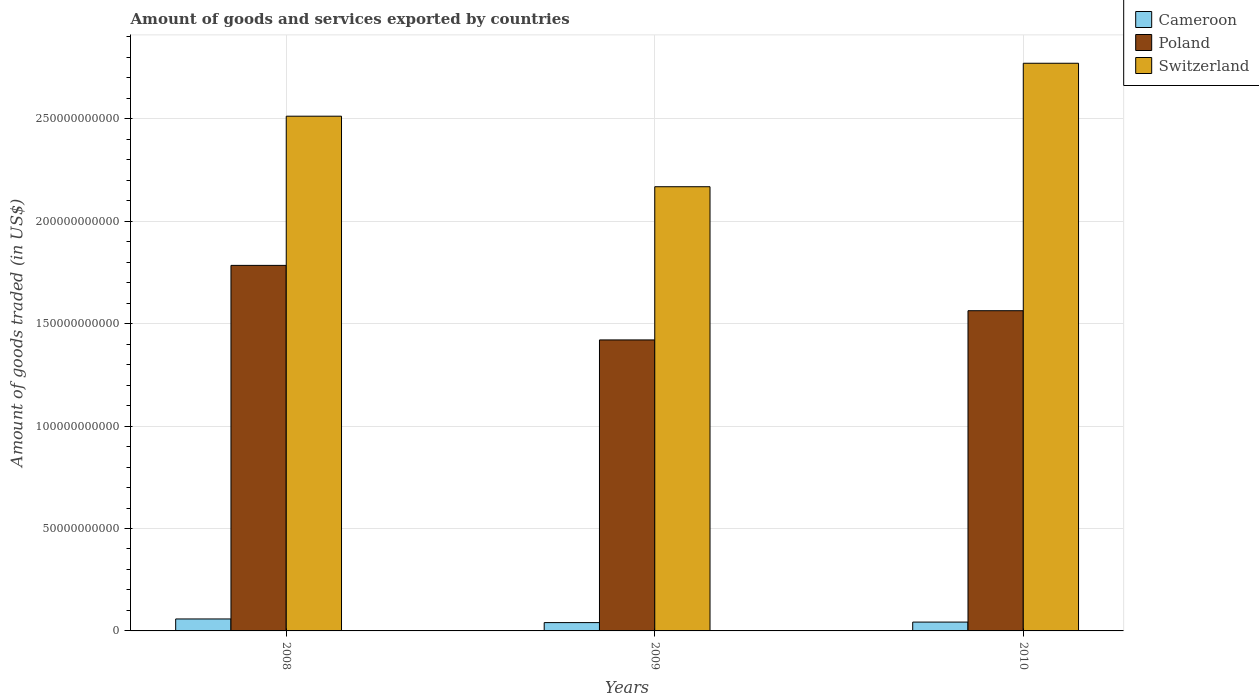How many different coloured bars are there?
Make the answer very short. 3. Are the number of bars on each tick of the X-axis equal?
Ensure brevity in your answer.  Yes. How many bars are there on the 3rd tick from the left?
Give a very brief answer. 3. How many bars are there on the 1st tick from the right?
Provide a short and direct response. 3. What is the total amount of goods and services exported in Cameroon in 2009?
Provide a succinct answer. 4.06e+09. Across all years, what is the maximum total amount of goods and services exported in Switzerland?
Provide a short and direct response. 2.77e+11. Across all years, what is the minimum total amount of goods and services exported in Switzerland?
Your response must be concise. 2.17e+11. What is the total total amount of goods and services exported in Poland in the graph?
Provide a succinct answer. 4.77e+11. What is the difference between the total amount of goods and services exported in Switzerland in 2008 and that in 2010?
Make the answer very short. -2.58e+1. What is the difference between the total amount of goods and services exported in Cameroon in 2010 and the total amount of goods and services exported in Switzerland in 2009?
Provide a short and direct response. -2.13e+11. What is the average total amount of goods and services exported in Switzerland per year?
Your answer should be very brief. 2.48e+11. In the year 2009, what is the difference between the total amount of goods and services exported in Cameroon and total amount of goods and services exported in Switzerland?
Your response must be concise. -2.13e+11. What is the ratio of the total amount of goods and services exported in Switzerland in 2008 to that in 2009?
Offer a very short reply. 1.16. Is the difference between the total amount of goods and services exported in Cameroon in 2008 and 2010 greater than the difference between the total amount of goods and services exported in Switzerland in 2008 and 2010?
Provide a succinct answer. Yes. What is the difference between the highest and the second highest total amount of goods and services exported in Switzerland?
Provide a succinct answer. 2.58e+1. What is the difference between the highest and the lowest total amount of goods and services exported in Switzerland?
Offer a terse response. 6.03e+1. In how many years, is the total amount of goods and services exported in Poland greater than the average total amount of goods and services exported in Poland taken over all years?
Your answer should be very brief. 1. What does the 2nd bar from the left in 2010 represents?
Your answer should be very brief. Poland. What does the 1st bar from the right in 2010 represents?
Provide a succinct answer. Switzerland. Is it the case that in every year, the sum of the total amount of goods and services exported in Switzerland and total amount of goods and services exported in Cameroon is greater than the total amount of goods and services exported in Poland?
Offer a terse response. Yes. Are all the bars in the graph horizontal?
Provide a succinct answer. No. How many years are there in the graph?
Provide a succinct answer. 3. Are the values on the major ticks of Y-axis written in scientific E-notation?
Ensure brevity in your answer.  No. Does the graph contain any zero values?
Make the answer very short. No. What is the title of the graph?
Your answer should be compact. Amount of goods and services exported by countries. Does "Turkmenistan" appear as one of the legend labels in the graph?
Offer a terse response. No. What is the label or title of the Y-axis?
Give a very brief answer. Amount of goods traded (in US$). What is the Amount of goods traded (in US$) in Cameroon in 2008?
Your answer should be compact. 5.84e+09. What is the Amount of goods traded (in US$) in Poland in 2008?
Ensure brevity in your answer.  1.78e+11. What is the Amount of goods traded (in US$) in Switzerland in 2008?
Make the answer very short. 2.51e+11. What is the Amount of goods traded (in US$) in Cameroon in 2009?
Make the answer very short. 4.06e+09. What is the Amount of goods traded (in US$) in Poland in 2009?
Offer a terse response. 1.42e+11. What is the Amount of goods traded (in US$) of Switzerland in 2009?
Provide a short and direct response. 2.17e+11. What is the Amount of goods traded (in US$) in Cameroon in 2010?
Keep it short and to the point. 4.31e+09. What is the Amount of goods traded (in US$) in Poland in 2010?
Offer a terse response. 1.56e+11. What is the Amount of goods traded (in US$) in Switzerland in 2010?
Offer a terse response. 2.77e+11. Across all years, what is the maximum Amount of goods traded (in US$) in Cameroon?
Give a very brief answer. 5.84e+09. Across all years, what is the maximum Amount of goods traded (in US$) of Poland?
Offer a very short reply. 1.78e+11. Across all years, what is the maximum Amount of goods traded (in US$) in Switzerland?
Make the answer very short. 2.77e+11. Across all years, what is the minimum Amount of goods traded (in US$) of Cameroon?
Make the answer very short. 4.06e+09. Across all years, what is the minimum Amount of goods traded (in US$) of Poland?
Your response must be concise. 1.42e+11. Across all years, what is the minimum Amount of goods traded (in US$) of Switzerland?
Your answer should be compact. 2.17e+11. What is the total Amount of goods traded (in US$) in Cameroon in the graph?
Offer a terse response. 1.42e+1. What is the total Amount of goods traded (in US$) in Poland in the graph?
Your answer should be compact. 4.77e+11. What is the total Amount of goods traded (in US$) of Switzerland in the graph?
Keep it short and to the point. 7.45e+11. What is the difference between the Amount of goods traded (in US$) in Cameroon in 2008 and that in 2009?
Your answer should be very brief. 1.78e+09. What is the difference between the Amount of goods traded (in US$) in Poland in 2008 and that in 2009?
Give a very brief answer. 3.64e+1. What is the difference between the Amount of goods traded (in US$) of Switzerland in 2008 and that in 2009?
Give a very brief answer. 3.44e+1. What is the difference between the Amount of goods traded (in US$) of Cameroon in 2008 and that in 2010?
Give a very brief answer. 1.53e+09. What is the difference between the Amount of goods traded (in US$) of Poland in 2008 and that in 2010?
Provide a short and direct response. 2.21e+1. What is the difference between the Amount of goods traded (in US$) of Switzerland in 2008 and that in 2010?
Your answer should be very brief. -2.58e+1. What is the difference between the Amount of goods traded (in US$) of Cameroon in 2009 and that in 2010?
Give a very brief answer. -2.49e+08. What is the difference between the Amount of goods traded (in US$) in Poland in 2009 and that in 2010?
Ensure brevity in your answer.  -1.43e+1. What is the difference between the Amount of goods traded (in US$) in Switzerland in 2009 and that in 2010?
Keep it short and to the point. -6.03e+1. What is the difference between the Amount of goods traded (in US$) of Cameroon in 2008 and the Amount of goods traded (in US$) of Poland in 2009?
Your answer should be very brief. -1.36e+11. What is the difference between the Amount of goods traded (in US$) of Cameroon in 2008 and the Amount of goods traded (in US$) of Switzerland in 2009?
Your answer should be very brief. -2.11e+11. What is the difference between the Amount of goods traded (in US$) in Poland in 2008 and the Amount of goods traded (in US$) in Switzerland in 2009?
Your answer should be compact. -3.84e+1. What is the difference between the Amount of goods traded (in US$) of Cameroon in 2008 and the Amount of goods traded (in US$) of Poland in 2010?
Make the answer very short. -1.51e+11. What is the difference between the Amount of goods traded (in US$) in Cameroon in 2008 and the Amount of goods traded (in US$) in Switzerland in 2010?
Make the answer very short. -2.71e+11. What is the difference between the Amount of goods traded (in US$) in Poland in 2008 and the Amount of goods traded (in US$) in Switzerland in 2010?
Provide a short and direct response. -9.87e+1. What is the difference between the Amount of goods traded (in US$) in Cameroon in 2009 and the Amount of goods traded (in US$) in Poland in 2010?
Your answer should be very brief. -1.52e+11. What is the difference between the Amount of goods traded (in US$) in Cameroon in 2009 and the Amount of goods traded (in US$) in Switzerland in 2010?
Ensure brevity in your answer.  -2.73e+11. What is the difference between the Amount of goods traded (in US$) of Poland in 2009 and the Amount of goods traded (in US$) of Switzerland in 2010?
Give a very brief answer. -1.35e+11. What is the average Amount of goods traded (in US$) of Cameroon per year?
Your answer should be compact. 4.74e+09. What is the average Amount of goods traded (in US$) of Poland per year?
Make the answer very short. 1.59e+11. What is the average Amount of goods traded (in US$) of Switzerland per year?
Provide a short and direct response. 2.48e+11. In the year 2008, what is the difference between the Amount of goods traded (in US$) of Cameroon and Amount of goods traded (in US$) of Poland?
Your answer should be compact. -1.73e+11. In the year 2008, what is the difference between the Amount of goods traded (in US$) in Cameroon and Amount of goods traded (in US$) in Switzerland?
Offer a terse response. -2.45e+11. In the year 2008, what is the difference between the Amount of goods traded (in US$) in Poland and Amount of goods traded (in US$) in Switzerland?
Offer a terse response. -7.28e+1. In the year 2009, what is the difference between the Amount of goods traded (in US$) of Cameroon and Amount of goods traded (in US$) of Poland?
Your answer should be very brief. -1.38e+11. In the year 2009, what is the difference between the Amount of goods traded (in US$) of Cameroon and Amount of goods traded (in US$) of Switzerland?
Provide a short and direct response. -2.13e+11. In the year 2009, what is the difference between the Amount of goods traded (in US$) of Poland and Amount of goods traded (in US$) of Switzerland?
Offer a terse response. -7.48e+1. In the year 2010, what is the difference between the Amount of goods traded (in US$) in Cameroon and Amount of goods traded (in US$) in Poland?
Ensure brevity in your answer.  -1.52e+11. In the year 2010, what is the difference between the Amount of goods traded (in US$) of Cameroon and Amount of goods traded (in US$) of Switzerland?
Make the answer very short. -2.73e+11. In the year 2010, what is the difference between the Amount of goods traded (in US$) of Poland and Amount of goods traded (in US$) of Switzerland?
Your answer should be very brief. -1.21e+11. What is the ratio of the Amount of goods traded (in US$) in Cameroon in 2008 to that in 2009?
Ensure brevity in your answer.  1.44. What is the ratio of the Amount of goods traded (in US$) of Poland in 2008 to that in 2009?
Your answer should be very brief. 1.26. What is the ratio of the Amount of goods traded (in US$) in Switzerland in 2008 to that in 2009?
Your answer should be very brief. 1.16. What is the ratio of the Amount of goods traded (in US$) in Cameroon in 2008 to that in 2010?
Ensure brevity in your answer.  1.35. What is the ratio of the Amount of goods traded (in US$) in Poland in 2008 to that in 2010?
Offer a very short reply. 1.14. What is the ratio of the Amount of goods traded (in US$) of Switzerland in 2008 to that in 2010?
Offer a terse response. 0.91. What is the ratio of the Amount of goods traded (in US$) in Cameroon in 2009 to that in 2010?
Keep it short and to the point. 0.94. What is the ratio of the Amount of goods traded (in US$) of Poland in 2009 to that in 2010?
Provide a succinct answer. 0.91. What is the ratio of the Amount of goods traded (in US$) in Switzerland in 2009 to that in 2010?
Provide a short and direct response. 0.78. What is the difference between the highest and the second highest Amount of goods traded (in US$) of Cameroon?
Your answer should be very brief. 1.53e+09. What is the difference between the highest and the second highest Amount of goods traded (in US$) of Poland?
Ensure brevity in your answer.  2.21e+1. What is the difference between the highest and the second highest Amount of goods traded (in US$) in Switzerland?
Offer a very short reply. 2.58e+1. What is the difference between the highest and the lowest Amount of goods traded (in US$) of Cameroon?
Make the answer very short. 1.78e+09. What is the difference between the highest and the lowest Amount of goods traded (in US$) of Poland?
Keep it short and to the point. 3.64e+1. What is the difference between the highest and the lowest Amount of goods traded (in US$) of Switzerland?
Give a very brief answer. 6.03e+1. 